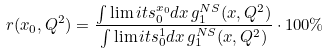<formula> <loc_0><loc_0><loc_500><loc_500>r ( x _ { 0 } , Q ^ { 2 } ) = \frac { \int \lim i t s _ { 0 } ^ { x _ { 0 } } d x \, g _ { 1 } ^ { N S } ( x , Q ^ { 2 } ) } { \int \lim i t s _ { 0 } ^ { 1 } d x \, g _ { 1 } ^ { N S } ( x , Q ^ { 2 } ) } \cdot 1 0 0 \%</formula> 